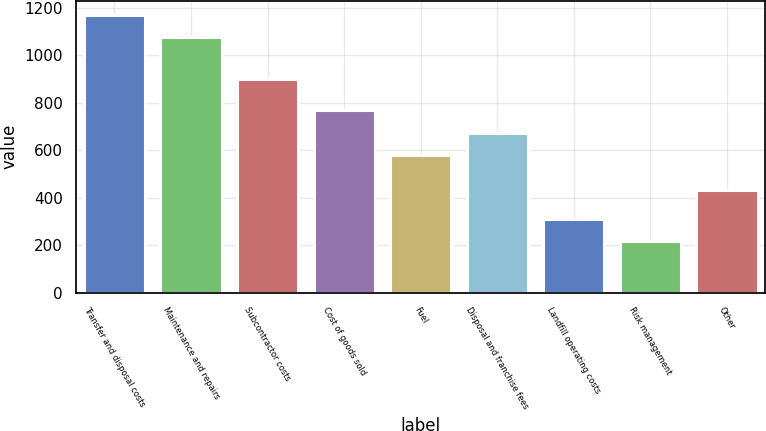Convert chart. <chart><loc_0><loc_0><loc_500><loc_500><bar_chart><fcel>Transfer and disposal costs<fcel>Maintenance and repairs<fcel>Subcontractor costs<fcel>Cost of goods sold<fcel>Fuel<fcel>Disposal and franchise fees<fcel>Landfill operating costs<fcel>Risk management<fcel>Other<nl><fcel>1172.1<fcel>1079<fcel>902<fcel>769<fcel>581<fcel>674.1<fcel>310.1<fcel>217<fcel>431<nl></chart> 